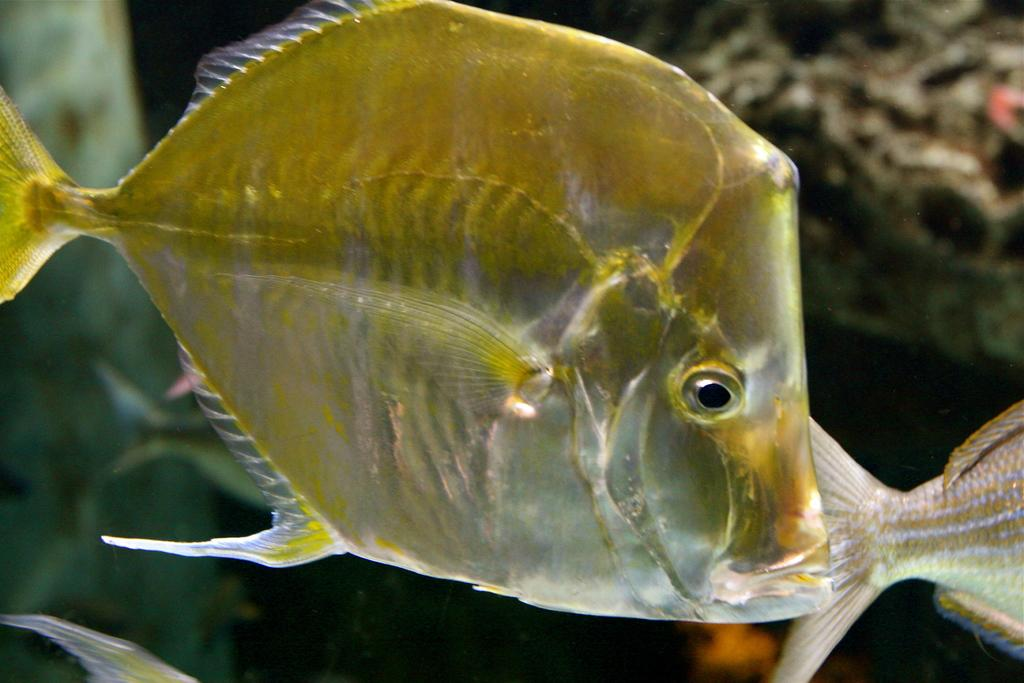What type of animals can be seen in the image? There are fish in the picture. Can you describe the background of the image? The background of the image is blurred. What type of store can be seen in the image? There is no store present in the image; it features fish and a blurred background. How much profit does the cushion in the image generate? There is no cushion present in the image, so it is not possible to determine its profitability. 